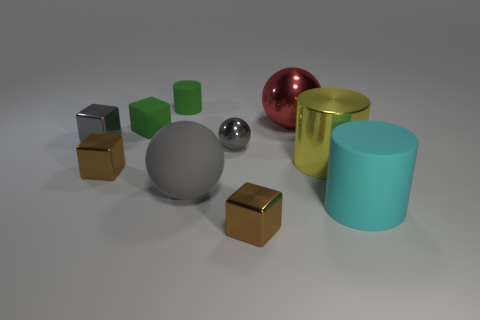What is the shape of the small matte thing that is the same color as the tiny rubber cylinder?
Make the answer very short. Cube. How many other objects are there of the same shape as the large gray matte thing?
Your answer should be very brief. 2. The cylinder that is the same size as the gray metal cube is what color?
Make the answer very short. Green. There is a cube to the right of the tiny cylinder; what is its color?
Ensure brevity in your answer.  Brown. Are there any cyan objects that are right of the matte cylinder to the right of the large yellow object?
Provide a succinct answer. No. Do the cyan matte object and the small brown object that is behind the large cyan object have the same shape?
Give a very brief answer. No. How big is the object that is behind the green block and left of the small ball?
Ensure brevity in your answer.  Small. Are there any small things made of the same material as the small gray ball?
Make the answer very short. Yes. There is a object that is the same color as the matte block; what size is it?
Offer a very short reply. Small. The brown object that is on the right side of the tiny brown block that is to the left of the small green rubber cylinder is made of what material?
Provide a succinct answer. Metal. 